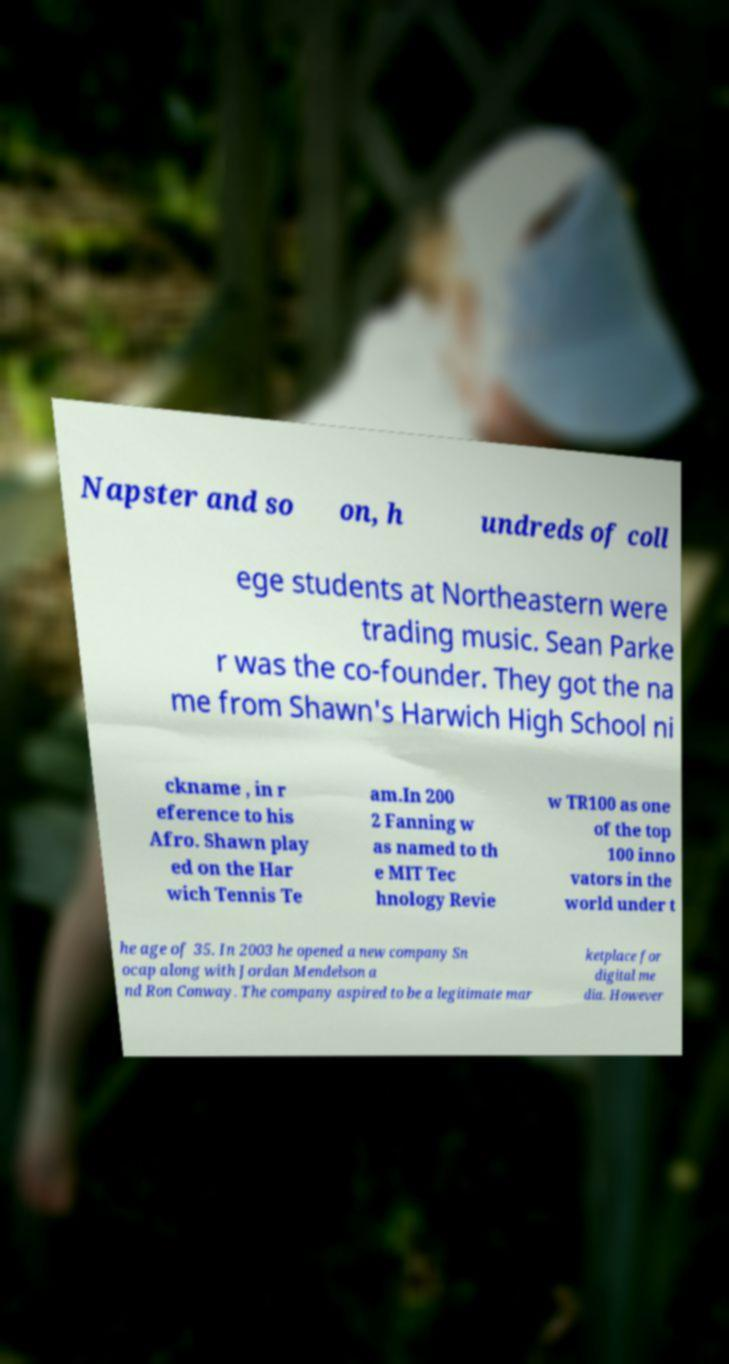For documentation purposes, I need the text within this image transcribed. Could you provide that? Napster and so on, h undreds of coll ege students at Northeastern were trading music. Sean Parke r was the co-founder. They got the na me from Shawn's Harwich High School ni ckname , in r eference to his Afro. Shawn play ed on the Har wich Tennis Te am.In 200 2 Fanning w as named to th e MIT Tec hnology Revie w TR100 as one of the top 100 inno vators in the world under t he age of 35. In 2003 he opened a new company Sn ocap along with Jordan Mendelson a nd Ron Conway. The company aspired to be a legitimate mar ketplace for digital me dia. However 